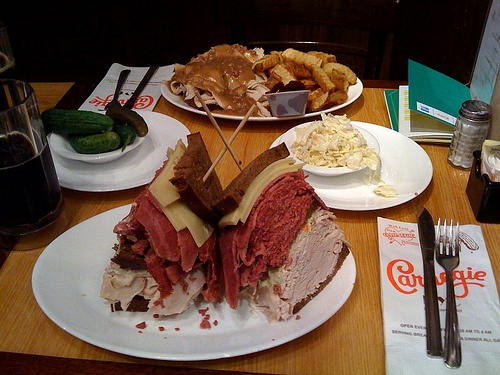Describe the objects in this image and their specific colors. I can see sandwich in black, maroon, gray, and darkgray tones, sandwich in black, maroon, tan, and brown tones, chair in black, brown, and maroon tones, bottle in black, maroon, and gray tones, and cake in black, darkgray, gray, and maroon tones in this image. 